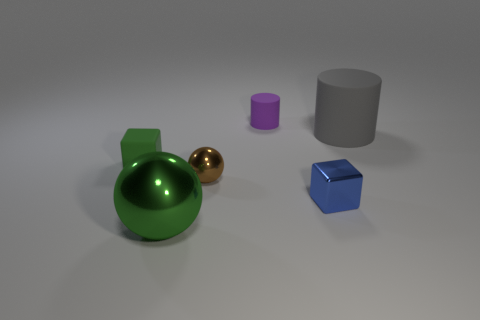Does the matte thing in front of the large gray object have the same color as the big sphere that is to the left of the purple thing?
Give a very brief answer. Yes. Are there any purple matte things on the right side of the tiny purple rubber cylinder?
Provide a succinct answer. No. There is a cylinder that is to the left of the block to the right of the block behind the brown shiny sphere; how big is it?
Make the answer very short. Small. There is a shiny thing that is behind the small blue metal cube; is its shape the same as the big object in front of the large gray object?
Provide a short and direct response. Yes. The other brown thing that is the same shape as the large metallic thing is what size?
Give a very brief answer. Small. How many other gray objects are made of the same material as the gray thing?
Provide a succinct answer. 0. What is the tiny brown sphere made of?
Keep it short and to the point. Metal. There is a big thing that is in front of the tiny cube left of the small blue cube; what shape is it?
Your response must be concise. Sphere. The tiny matte thing that is in front of the purple matte cylinder has what shape?
Your response must be concise. Cube. What number of small matte cubes are the same color as the big metal ball?
Your answer should be compact. 1. 